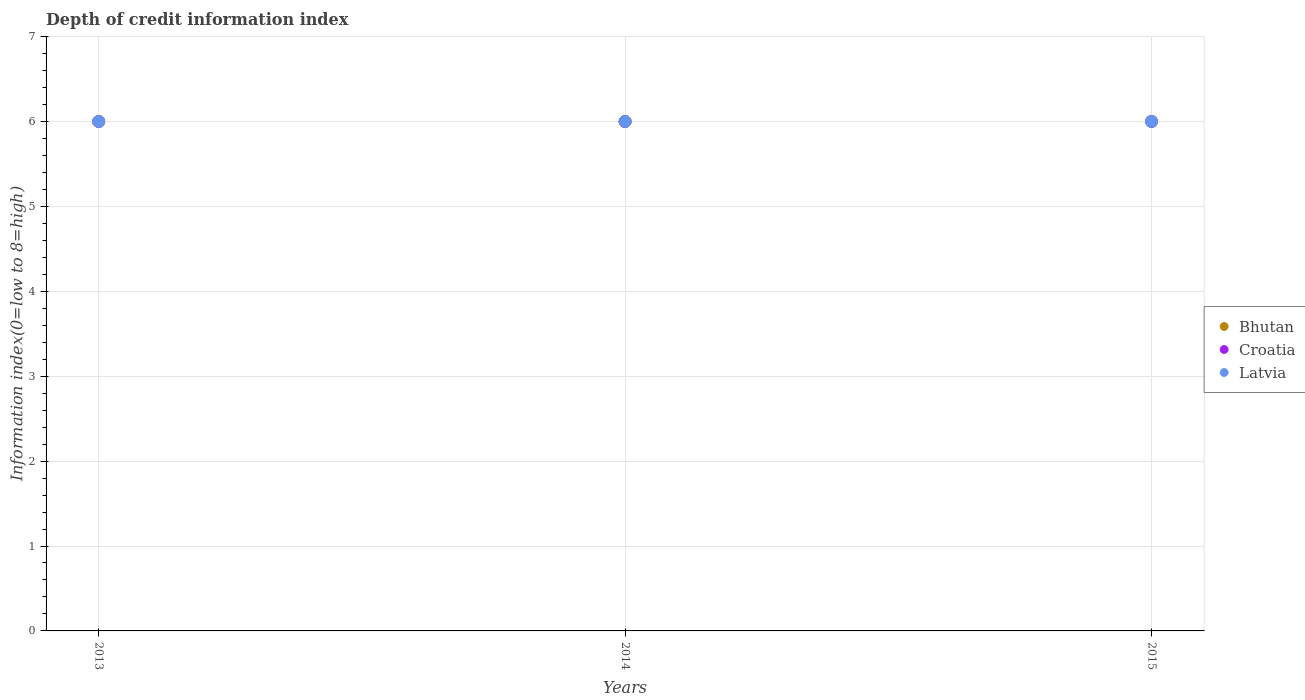Is the number of dotlines equal to the number of legend labels?
Give a very brief answer. Yes. Across all years, what is the maximum information index in Latvia?
Offer a very short reply. 6. In which year was the information index in Croatia minimum?
Keep it short and to the point. 2013. What is the total information index in Latvia in the graph?
Offer a very short reply. 18. What is the difference between the information index in Bhutan in 2013 and the information index in Latvia in 2014?
Your answer should be compact. 0. What is the average information index in Bhutan per year?
Your answer should be compact. 6. In how many years, is the information index in Croatia greater than 0.2?
Offer a very short reply. 3. What is the ratio of the information index in Croatia in 2014 to that in 2015?
Give a very brief answer. 1. In how many years, is the information index in Latvia greater than the average information index in Latvia taken over all years?
Provide a short and direct response. 0. Is it the case that in every year, the sum of the information index in Croatia and information index in Latvia  is greater than the information index in Bhutan?
Provide a succinct answer. Yes. Is the information index in Latvia strictly greater than the information index in Bhutan over the years?
Provide a succinct answer. No. Is the information index in Latvia strictly less than the information index in Croatia over the years?
Your response must be concise. No. Does the graph contain any zero values?
Your answer should be compact. No. Does the graph contain grids?
Offer a very short reply. Yes. How many legend labels are there?
Offer a terse response. 3. What is the title of the graph?
Provide a succinct answer. Depth of credit information index. Does "Oman" appear as one of the legend labels in the graph?
Provide a short and direct response. No. What is the label or title of the Y-axis?
Provide a short and direct response. Information index(0=low to 8=high). What is the Information index(0=low to 8=high) in Bhutan in 2013?
Offer a terse response. 6. What is the Information index(0=low to 8=high) in Croatia in 2013?
Offer a terse response. 6. What is the Information index(0=low to 8=high) in Croatia in 2014?
Offer a very short reply. 6. What is the Information index(0=low to 8=high) of Latvia in 2014?
Make the answer very short. 6. What is the Information index(0=low to 8=high) in Bhutan in 2015?
Your response must be concise. 6. Across all years, what is the maximum Information index(0=low to 8=high) in Bhutan?
Ensure brevity in your answer.  6. Across all years, what is the minimum Information index(0=low to 8=high) in Latvia?
Ensure brevity in your answer.  6. What is the difference between the Information index(0=low to 8=high) in Bhutan in 2013 and that in 2014?
Provide a succinct answer. 0. What is the difference between the Information index(0=low to 8=high) in Croatia in 2013 and that in 2014?
Make the answer very short. 0. What is the difference between the Information index(0=low to 8=high) of Latvia in 2013 and that in 2014?
Your answer should be compact. 0. What is the difference between the Information index(0=low to 8=high) in Bhutan in 2013 and that in 2015?
Your answer should be compact. 0. What is the difference between the Information index(0=low to 8=high) of Croatia in 2014 and that in 2015?
Your answer should be compact. 0. What is the difference between the Information index(0=low to 8=high) of Bhutan in 2013 and the Information index(0=low to 8=high) of Croatia in 2015?
Your answer should be very brief. 0. What is the difference between the Information index(0=low to 8=high) in Bhutan in 2013 and the Information index(0=low to 8=high) in Latvia in 2015?
Your answer should be very brief. 0. What is the difference between the Information index(0=low to 8=high) of Croatia in 2013 and the Information index(0=low to 8=high) of Latvia in 2015?
Provide a succinct answer. 0. What is the difference between the Information index(0=low to 8=high) in Bhutan in 2014 and the Information index(0=low to 8=high) in Croatia in 2015?
Provide a short and direct response. 0. What is the average Information index(0=low to 8=high) in Bhutan per year?
Offer a very short reply. 6. In the year 2013, what is the difference between the Information index(0=low to 8=high) of Bhutan and Information index(0=low to 8=high) of Croatia?
Your response must be concise. 0. In the year 2013, what is the difference between the Information index(0=low to 8=high) in Bhutan and Information index(0=low to 8=high) in Latvia?
Keep it short and to the point. 0. In the year 2013, what is the difference between the Information index(0=low to 8=high) of Croatia and Information index(0=low to 8=high) of Latvia?
Offer a very short reply. 0. In the year 2014, what is the difference between the Information index(0=low to 8=high) in Bhutan and Information index(0=low to 8=high) in Croatia?
Keep it short and to the point. 0. In the year 2014, what is the difference between the Information index(0=low to 8=high) in Bhutan and Information index(0=low to 8=high) in Latvia?
Offer a terse response. 0. In the year 2015, what is the difference between the Information index(0=low to 8=high) in Bhutan and Information index(0=low to 8=high) in Croatia?
Keep it short and to the point. 0. In the year 2015, what is the difference between the Information index(0=low to 8=high) of Bhutan and Information index(0=low to 8=high) of Latvia?
Provide a short and direct response. 0. In the year 2015, what is the difference between the Information index(0=low to 8=high) of Croatia and Information index(0=low to 8=high) of Latvia?
Your answer should be very brief. 0. What is the ratio of the Information index(0=low to 8=high) in Latvia in 2013 to that in 2014?
Your response must be concise. 1. What is the ratio of the Information index(0=low to 8=high) of Croatia in 2014 to that in 2015?
Ensure brevity in your answer.  1. What is the difference between the highest and the second highest Information index(0=low to 8=high) in Croatia?
Give a very brief answer. 0. What is the difference between the highest and the second highest Information index(0=low to 8=high) of Latvia?
Give a very brief answer. 0. What is the difference between the highest and the lowest Information index(0=low to 8=high) in Bhutan?
Give a very brief answer. 0. What is the difference between the highest and the lowest Information index(0=low to 8=high) of Latvia?
Offer a terse response. 0. 